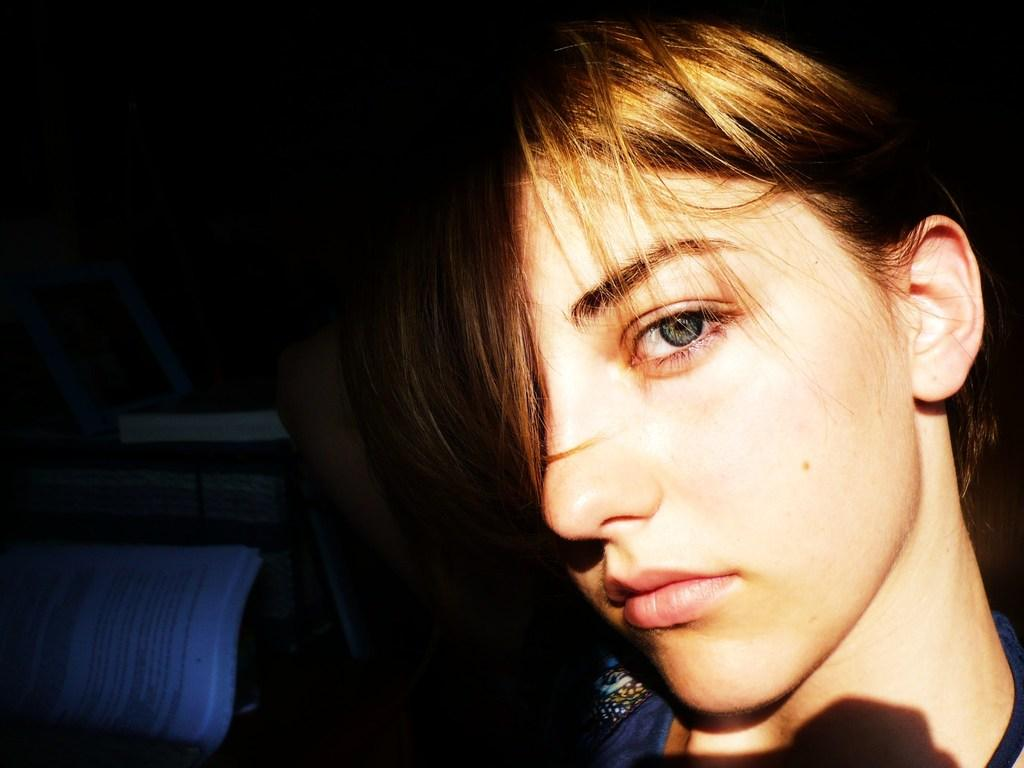What is the person in the image wearing? The person is wearing a navy blue color dress in the image. What can be seen to the left of the person? There are papers visible to the left of the person. What color is the background of the image? The background of the image is black. What type of stove can be seen in the image? There is no stove present in the image. How many yams are visible on the person's dress? There are no yams depicted on the person's dress in the image. 